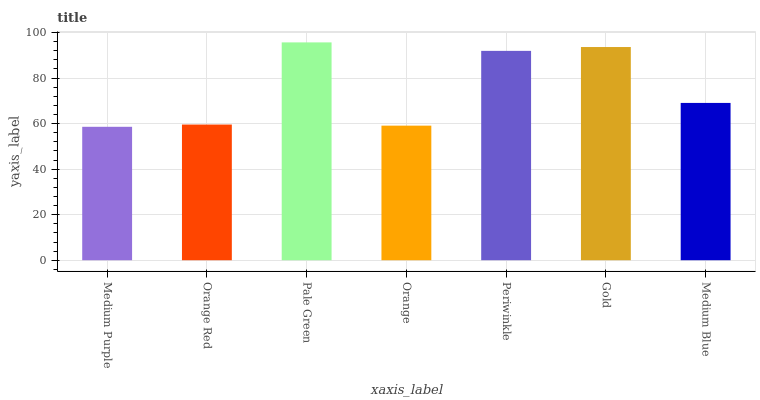Is Medium Purple the minimum?
Answer yes or no. Yes. Is Pale Green the maximum?
Answer yes or no. Yes. Is Orange Red the minimum?
Answer yes or no. No. Is Orange Red the maximum?
Answer yes or no. No. Is Orange Red greater than Medium Purple?
Answer yes or no. Yes. Is Medium Purple less than Orange Red?
Answer yes or no. Yes. Is Medium Purple greater than Orange Red?
Answer yes or no. No. Is Orange Red less than Medium Purple?
Answer yes or no. No. Is Medium Blue the high median?
Answer yes or no. Yes. Is Medium Blue the low median?
Answer yes or no. Yes. Is Periwinkle the high median?
Answer yes or no. No. Is Orange the low median?
Answer yes or no. No. 